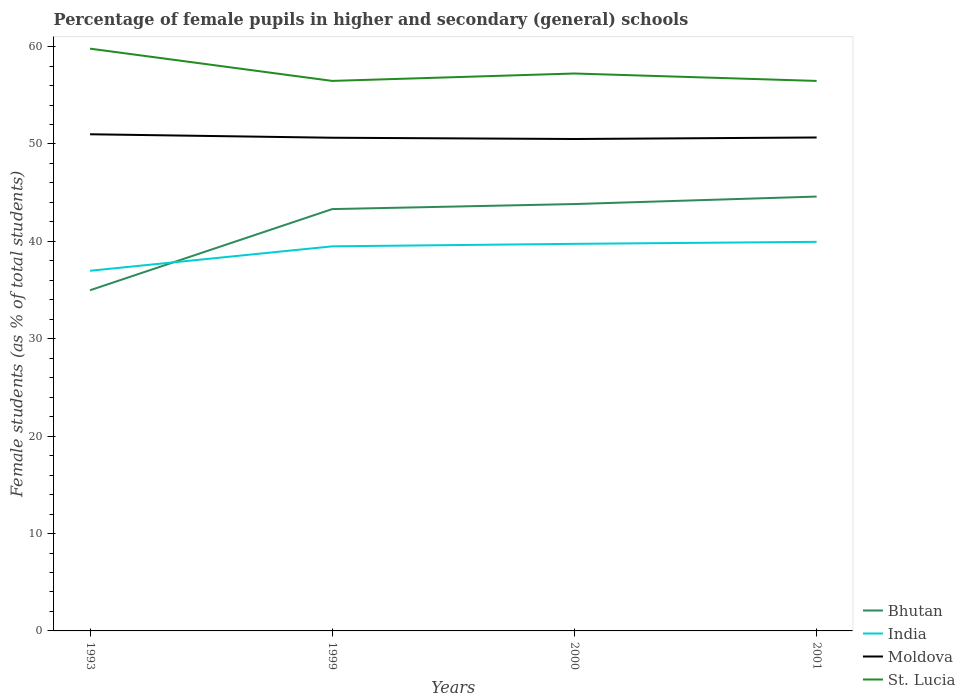How many different coloured lines are there?
Ensure brevity in your answer.  4. Across all years, what is the maximum percentage of female pupils in higher and secondary schools in Moldova?
Ensure brevity in your answer.  50.51. In which year was the percentage of female pupils in higher and secondary schools in Moldova maximum?
Give a very brief answer. 2000. What is the total percentage of female pupils in higher and secondary schools in St. Lucia in the graph?
Make the answer very short. 3.31. What is the difference between the highest and the second highest percentage of female pupils in higher and secondary schools in St. Lucia?
Ensure brevity in your answer.  3.31. What is the difference between the highest and the lowest percentage of female pupils in higher and secondary schools in Bhutan?
Your answer should be very brief. 3. How many years are there in the graph?
Offer a very short reply. 4. Does the graph contain grids?
Offer a terse response. No. What is the title of the graph?
Give a very brief answer. Percentage of female pupils in higher and secondary (general) schools. What is the label or title of the Y-axis?
Provide a short and direct response. Female students (as % of total students). What is the Female students (as % of total students) of Bhutan in 1993?
Give a very brief answer. 34.98. What is the Female students (as % of total students) in India in 1993?
Keep it short and to the point. 36.98. What is the Female students (as % of total students) in Moldova in 1993?
Give a very brief answer. 51. What is the Female students (as % of total students) in St. Lucia in 1993?
Provide a short and direct response. 59.79. What is the Female students (as % of total students) of Bhutan in 1999?
Your answer should be very brief. 43.32. What is the Female students (as % of total students) in India in 1999?
Your answer should be compact. 39.49. What is the Female students (as % of total students) in Moldova in 1999?
Offer a very short reply. 50.64. What is the Female students (as % of total students) in St. Lucia in 1999?
Keep it short and to the point. 56.48. What is the Female students (as % of total students) of Bhutan in 2000?
Make the answer very short. 43.83. What is the Female students (as % of total students) of India in 2000?
Ensure brevity in your answer.  39.75. What is the Female students (as % of total students) of Moldova in 2000?
Provide a short and direct response. 50.51. What is the Female students (as % of total students) in St. Lucia in 2000?
Your response must be concise. 57.24. What is the Female students (as % of total students) in Bhutan in 2001?
Provide a succinct answer. 44.6. What is the Female students (as % of total students) of India in 2001?
Provide a short and direct response. 39.95. What is the Female students (as % of total students) in Moldova in 2001?
Offer a very short reply. 50.67. What is the Female students (as % of total students) of St. Lucia in 2001?
Your answer should be compact. 56.48. Across all years, what is the maximum Female students (as % of total students) in Bhutan?
Ensure brevity in your answer.  44.6. Across all years, what is the maximum Female students (as % of total students) of India?
Ensure brevity in your answer.  39.95. Across all years, what is the maximum Female students (as % of total students) in Moldova?
Ensure brevity in your answer.  51. Across all years, what is the maximum Female students (as % of total students) of St. Lucia?
Make the answer very short. 59.79. Across all years, what is the minimum Female students (as % of total students) of Bhutan?
Provide a succinct answer. 34.98. Across all years, what is the minimum Female students (as % of total students) of India?
Ensure brevity in your answer.  36.98. Across all years, what is the minimum Female students (as % of total students) of Moldova?
Your response must be concise. 50.51. Across all years, what is the minimum Female students (as % of total students) in St. Lucia?
Offer a very short reply. 56.48. What is the total Female students (as % of total students) in Bhutan in the graph?
Provide a short and direct response. 166.73. What is the total Female students (as % of total students) in India in the graph?
Ensure brevity in your answer.  156.18. What is the total Female students (as % of total students) of Moldova in the graph?
Give a very brief answer. 202.83. What is the total Female students (as % of total students) in St. Lucia in the graph?
Provide a short and direct response. 229.98. What is the difference between the Female students (as % of total students) of Bhutan in 1993 and that in 1999?
Give a very brief answer. -8.33. What is the difference between the Female students (as % of total students) in India in 1993 and that in 1999?
Give a very brief answer. -2.51. What is the difference between the Female students (as % of total students) in Moldova in 1993 and that in 1999?
Your response must be concise. 0.36. What is the difference between the Female students (as % of total students) in St. Lucia in 1993 and that in 1999?
Offer a very short reply. 3.31. What is the difference between the Female students (as % of total students) of Bhutan in 1993 and that in 2000?
Keep it short and to the point. -8.85. What is the difference between the Female students (as % of total students) in India in 1993 and that in 2000?
Your response must be concise. -2.76. What is the difference between the Female students (as % of total students) in Moldova in 1993 and that in 2000?
Keep it short and to the point. 0.49. What is the difference between the Female students (as % of total students) of St. Lucia in 1993 and that in 2000?
Offer a terse response. 2.55. What is the difference between the Female students (as % of total students) of Bhutan in 1993 and that in 2001?
Provide a succinct answer. -9.62. What is the difference between the Female students (as % of total students) of India in 1993 and that in 2001?
Offer a very short reply. -2.97. What is the difference between the Female students (as % of total students) of Moldova in 1993 and that in 2001?
Provide a short and direct response. 0.33. What is the difference between the Female students (as % of total students) in St. Lucia in 1993 and that in 2001?
Provide a short and direct response. 3.31. What is the difference between the Female students (as % of total students) of Bhutan in 1999 and that in 2000?
Ensure brevity in your answer.  -0.52. What is the difference between the Female students (as % of total students) of India in 1999 and that in 2000?
Your answer should be very brief. -0.26. What is the difference between the Female students (as % of total students) in Moldova in 1999 and that in 2000?
Give a very brief answer. 0.13. What is the difference between the Female students (as % of total students) in St. Lucia in 1999 and that in 2000?
Your response must be concise. -0.76. What is the difference between the Female students (as % of total students) in Bhutan in 1999 and that in 2001?
Offer a terse response. -1.29. What is the difference between the Female students (as % of total students) of India in 1999 and that in 2001?
Your response must be concise. -0.46. What is the difference between the Female students (as % of total students) of Moldova in 1999 and that in 2001?
Keep it short and to the point. -0.03. What is the difference between the Female students (as % of total students) of St. Lucia in 1999 and that in 2001?
Your response must be concise. 0. What is the difference between the Female students (as % of total students) of Bhutan in 2000 and that in 2001?
Offer a very short reply. -0.77. What is the difference between the Female students (as % of total students) of India in 2000 and that in 2001?
Make the answer very short. -0.21. What is the difference between the Female students (as % of total students) in Moldova in 2000 and that in 2001?
Make the answer very short. -0.16. What is the difference between the Female students (as % of total students) in St. Lucia in 2000 and that in 2001?
Offer a terse response. 0.76. What is the difference between the Female students (as % of total students) in Bhutan in 1993 and the Female students (as % of total students) in India in 1999?
Make the answer very short. -4.51. What is the difference between the Female students (as % of total students) in Bhutan in 1993 and the Female students (as % of total students) in Moldova in 1999?
Offer a very short reply. -15.66. What is the difference between the Female students (as % of total students) in Bhutan in 1993 and the Female students (as % of total students) in St. Lucia in 1999?
Ensure brevity in your answer.  -21.5. What is the difference between the Female students (as % of total students) of India in 1993 and the Female students (as % of total students) of Moldova in 1999?
Make the answer very short. -13.66. What is the difference between the Female students (as % of total students) in India in 1993 and the Female students (as % of total students) in St. Lucia in 1999?
Make the answer very short. -19.5. What is the difference between the Female students (as % of total students) of Moldova in 1993 and the Female students (as % of total students) of St. Lucia in 1999?
Offer a terse response. -5.48. What is the difference between the Female students (as % of total students) in Bhutan in 1993 and the Female students (as % of total students) in India in 2000?
Offer a terse response. -4.76. What is the difference between the Female students (as % of total students) of Bhutan in 1993 and the Female students (as % of total students) of Moldova in 2000?
Make the answer very short. -15.53. What is the difference between the Female students (as % of total students) of Bhutan in 1993 and the Female students (as % of total students) of St. Lucia in 2000?
Ensure brevity in your answer.  -22.26. What is the difference between the Female students (as % of total students) in India in 1993 and the Female students (as % of total students) in Moldova in 2000?
Your response must be concise. -13.53. What is the difference between the Female students (as % of total students) in India in 1993 and the Female students (as % of total students) in St. Lucia in 2000?
Your response must be concise. -20.26. What is the difference between the Female students (as % of total students) in Moldova in 1993 and the Female students (as % of total students) in St. Lucia in 2000?
Your answer should be compact. -6.24. What is the difference between the Female students (as % of total students) in Bhutan in 1993 and the Female students (as % of total students) in India in 2001?
Offer a very short reply. -4.97. What is the difference between the Female students (as % of total students) of Bhutan in 1993 and the Female students (as % of total students) of Moldova in 2001?
Keep it short and to the point. -15.69. What is the difference between the Female students (as % of total students) in Bhutan in 1993 and the Female students (as % of total students) in St. Lucia in 2001?
Your answer should be very brief. -21.49. What is the difference between the Female students (as % of total students) of India in 1993 and the Female students (as % of total students) of Moldova in 2001?
Provide a short and direct response. -13.69. What is the difference between the Female students (as % of total students) of India in 1993 and the Female students (as % of total students) of St. Lucia in 2001?
Your answer should be compact. -19.49. What is the difference between the Female students (as % of total students) of Moldova in 1993 and the Female students (as % of total students) of St. Lucia in 2001?
Make the answer very short. -5.48. What is the difference between the Female students (as % of total students) of Bhutan in 1999 and the Female students (as % of total students) of India in 2000?
Make the answer very short. 3.57. What is the difference between the Female students (as % of total students) of Bhutan in 1999 and the Female students (as % of total students) of Moldova in 2000?
Offer a terse response. -7.2. What is the difference between the Female students (as % of total students) in Bhutan in 1999 and the Female students (as % of total students) in St. Lucia in 2000?
Make the answer very short. -13.92. What is the difference between the Female students (as % of total students) in India in 1999 and the Female students (as % of total students) in Moldova in 2000?
Offer a terse response. -11.02. What is the difference between the Female students (as % of total students) in India in 1999 and the Female students (as % of total students) in St. Lucia in 2000?
Keep it short and to the point. -17.75. What is the difference between the Female students (as % of total students) of Moldova in 1999 and the Female students (as % of total students) of St. Lucia in 2000?
Provide a succinct answer. -6.6. What is the difference between the Female students (as % of total students) of Bhutan in 1999 and the Female students (as % of total students) of India in 2001?
Keep it short and to the point. 3.36. What is the difference between the Female students (as % of total students) in Bhutan in 1999 and the Female students (as % of total students) in Moldova in 2001?
Offer a very short reply. -7.35. What is the difference between the Female students (as % of total students) in Bhutan in 1999 and the Female students (as % of total students) in St. Lucia in 2001?
Your answer should be compact. -13.16. What is the difference between the Female students (as % of total students) in India in 1999 and the Female students (as % of total students) in Moldova in 2001?
Ensure brevity in your answer.  -11.18. What is the difference between the Female students (as % of total students) in India in 1999 and the Female students (as % of total students) in St. Lucia in 2001?
Provide a short and direct response. -16.98. What is the difference between the Female students (as % of total students) in Moldova in 1999 and the Female students (as % of total students) in St. Lucia in 2001?
Give a very brief answer. -5.83. What is the difference between the Female students (as % of total students) in Bhutan in 2000 and the Female students (as % of total students) in India in 2001?
Keep it short and to the point. 3.88. What is the difference between the Female students (as % of total students) of Bhutan in 2000 and the Female students (as % of total students) of Moldova in 2001?
Make the answer very short. -6.84. What is the difference between the Female students (as % of total students) of Bhutan in 2000 and the Female students (as % of total students) of St. Lucia in 2001?
Provide a succinct answer. -12.64. What is the difference between the Female students (as % of total students) of India in 2000 and the Female students (as % of total students) of Moldova in 2001?
Keep it short and to the point. -10.92. What is the difference between the Female students (as % of total students) in India in 2000 and the Female students (as % of total students) in St. Lucia in 2001?
Your response must be concise. -16.73. What is the difference between the Female students (as % of total students) in Moldova in 2000 and the Female students (as % of total students) in St. Lucia in 2001?
Keep it short and to the point. -5.96. What is the average Female students (as % of total students) in Bhutan per year?
Give a very brief answer. 41.68. What is the average Female students (as % of total students) of India per year?
Your response must be concise. 39.04. What is the average Female students (as % of total students) of Moldova per year?
Give a very brief answer. 50.71. What is the average Female students (as % of total students) in St. Lucia per year?
Your response must be concise. 57.5. In the year 1993, what is the difference between the Female students (as % of total students) of Bhutan and Female students (as % of total students) of India?
Your answer should be compact. -2. In the year 1993, what is the difference between the Female students (as % of total students) in Bhutan and Female students (as % of total students) in Moldova?
Offer a very short reply. -16.02. In the year 1993, what is the difference between the Female students (as % of total students) in Bhutan and Female students (as % of total students) in St. Lucia?
Your answer should be very brief. -24.81. In the year 1993, what is the difference between the Female students (as % of total students) of India and Female students (as % of total students) of Moldova?
Your answer should be compact. -14.02. In the year 1993, what is the difference between the Female students (as % of total students) of India and Female students (as % of total students) of St. Lucia?
Keep it short and to the point. -22.81. In the year 1993, what is the difference between the Female students (as % of total students) of Moldova and Female students (as % of total students) of St. Lucia?
Offer a very short reply. -8.79. In the year 1999, what is the difference between the Female students (as % of total students) of Bhutan and Female students (as % of total students) of India?
Ensure brevity in your answer.  3.82. In the year 1999, what is the difference between the Female students (as % of total students) of Bhutan and Female students (as % of total students) of Moldova?
Your response must be concise. -7.33. In the year 1999, what is the difference between the Female students (as % of total students) of Bhutan and Female students (as % of total students) of St. Lucia?
Keep it short and to the point. -13.16. In the year 1999, what is the difference between the Female students (as % of total students) in India and Female students (as % of total students) in Moldova?
Keep it short and to the point. -11.15. In the year 1999, what is the difference between the Female students (as % of total students) in India and Female students (as % of total students) in St. Lucia?
Offer a terse response. -16.99. In the year 1999, what is the difference between the Female students (as % of total students) of Moldova and Female students (as % of total students) of St. Lucia?
Your response must be concise. -5.84. In the year 2000, what is the difference between the Female students (as % of total students) of Bhutan and Female students (as % of total students) of India?
Give a very brief answer. 4.09. In the year 2000, what is the difference between the Female students (as % of total students) of Bhutan and Female students (as % of total students) of Moldova?
Your answer should be very brief. -6.68. In the year 2000, what is the difference between the Female students (as % of total students) of Bhutan and Female students (as % of total students) of St. Lucia?
Make the answer very short. -13.41. In the year 2000, what is the difference between the Female students (as % of total students) in India and Female students (as % of total students) in Moldova?
Ensure brevity in your answer.  -10.77. In the year 2000, what is the difference between the Female students (as % of total students) of India and Female students (as % of total students) of St. Lucia?
Ensure brevity in your answer.  -17.49. In the year 2000, what is the difference between the Female students (as % of total students) in Moldova and Female students (as % of total students) in St. Lucia?
Your answer should be very brief. -6.72. In the year 2001, what is the difference between the Female students (as % of total students) in Bhutan and Female students (as % of total students) in India?
Offer a very short reply. 4.65. In the year 2001, what is the difference between the Female students (as % of total students) in Bhutan and Female students (as % of total students) in Moldova?
Your answer should be very brief. -6.07. In the year 2001, what is the difference between the Female students (as % of total students) of Bhutan and Female students (as % of total students) of St. Lucia?
Give a very brief answer. -11.87. In the year 2001, what is the difference between the Female students (as % of total students) of India and Female students (as % of total students) of Moldova?
Keep it short and to the point. -10.72. In the year 2001, what is the difference between the Female students (as % of total students) of India and Female students (as % of total students) of St. Lucia?
Ensure brevity in your answer.  -16.52. In the year 2001, what is the difference between the Female students (as % of total students) of Moldova and Female students (as % of total students) of St. Lucia?
Give a very brief answer. -5.81. What is the ratio of the Female students (as % of total students) of Bhutan in 1993 to that in 1999?
Make the answer very short. 0.81. What is the ratio of the Female students (as % of total students) in India in 1993 to that in 1999?
Keep it short and to the point. 0.94. What is the ratio of the Female students (as % of total students) in Moldova in 1993 to that in 1999?
Provide a succinct answer. 1.01. What is the ratio of the Female students (as % of total students) in St. Lucia in 1993 to that in 1999?
Provide a short and direct response. 1.06. What is the ratio of the Female students (as % of total students) in Bhutan in 1993 to that in 2000?
Offer a very short reply. 0.8. What is the ratio of the Female students (as % of total students) of India in 1993 to that in 2000?
Ensure brevity in your answer.  0.93. What is the ratio of the Female students (as % of total students) in Moldova in 1993 to that in 2000?
Give a very brief answer. 1.01. What is the ratio of the Female students (as % of total students) of St. Lucia in 1993 to that in 2000?
Make the answer very short. 1.04. What is the ratio of the Female students (as % of total students) of Bhutan in 1993 to that in 2001?
Make the answer very short. 0.78. What is the ratio of the Female students (as % of total students) in India in 1993 to that in 2001?
Ensure brevity in your answer.  0.93. What is the ratio of the Female students (as % of total students) of Moldova in 1993 to that in 2001?
Your response must be concise. 1.01. What is the ratio of the Female students (as % of total students) of St. Lucia in 1993 to that in 2001?
Offer a very short reply. 1.06. What is the ratio of the Female students (as % of total students) of Moldova in 1999 to that in 2000?
Provide a short and direct response. 1. What is the ratio of the Female students (as % of total students) of St. Lucia in 1999 to that in 2000?
Keep it short and to the point. 0.99. What is the ratio of the Female students (as % of total students) of Bhutan in 1999 to that in 2001?
Offer a very short reply. 0.97. What is the ratio of the Female students (as % of total students) in India in 1999 to that in 2001?
Your answer should be very brief. 0.99. What is the ratio of the Female students (as % of total students) in Moldova in 1999 to that in 2001?
Provide a short and direct response. 1. What is the ratio of the Female students (as % of total students) in St. Lucia in 1999 to that in 2001?
Offer a very short reply. 1. What is the ratio of the Female students (as % of total students) in Bhutan in 2000 to that in 2001?
Ensure brevity in your answer.  0.98. What is the ratio of the Female students (as % of total students) of Moldova in 2000 to that in 2001?
Provide a succinct answer. 1. What is the ratio of the Female students (as % of total students) of St. Lucia in 2000 to that in 2001?
Provide a short and direct response. 1.01. What is the difference between the highest and the second highest Female students (as % of total students) in Bhutan?
Offer a very short reply. 0.77. What is the difference between the highest and the second highest Female students (as % of total students) of India?
Offer a very short reply. 0.21. What is the difference between the highest and the second highest Female students (as % of total students) in Moldova?
Keep it short and to the point. 0.33. What is the difference between the highest and the second highest Female students (as % of total students) in St. Lucia?
Your response must be concise. 2.55. What is the difference between the highest and the lowest Female students (as % of total students) in Bhutan?
Give a very brief answer. 9.62. What is the difference between the highest and the lowest Female students (as % of total students) of India?
Offer a very short reply. 2.97. What is the difference between the highest and the lowest Female students (as % of total students) of Moldova?
Provide a short and direct response. 0.49. What is the difference between the highest and the lowest Female students (as % of total students) of St. Lucia?
Offer a terse response. 3.31. 